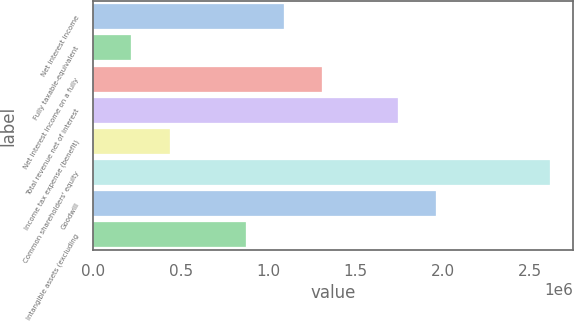Convert chart. <chart><loc_0><loc_0><loc_500><loc_500><bar_chart><fcel>Net interest income<fcel>Fully taxable-equivalent<fcel>Net interest income on a fully<fcel>Total revenue net of interest<fcel>Income tax expense (benefit)<fcel>Common shareholders' equity<fcel>Goodwill<fcel>Intangible assets (excluding<nl><fcel>1.09076e+06<fcel>218204<fcel>1.3089e+06<fcel>1.74517e+06<fcel>436343<fcel>2.61773e+06<fcel>1.96331e+06<fcel>872619<nl></chart> 